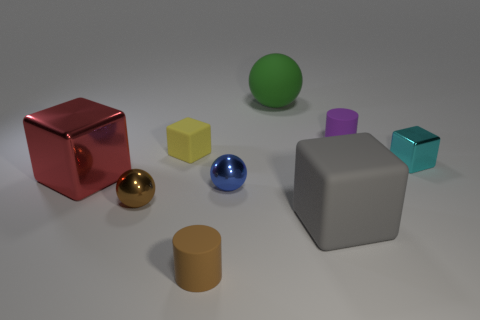Subtract all metal balls. How many balls are left? 1 Add 1 blue rubber objects. How many objects exist? 10 Subtract all balls. How many objects are left? 6 Subtract all green balls. How many balls are left? 2 Add 9 red things. How many red things are left? 10 Add 6 gray balls. How many gray balls exist? 6 Subtract 0 blue cylinders. How many objects are left? 9 Subtract 2 cylinders. How many cylinders are left? 0 Subtract all cyan blocks. Subtract all purple balls. How many blocks are left? 3 Subtract all big metallic things. Subtract all green balls. How many objects are left? 7 